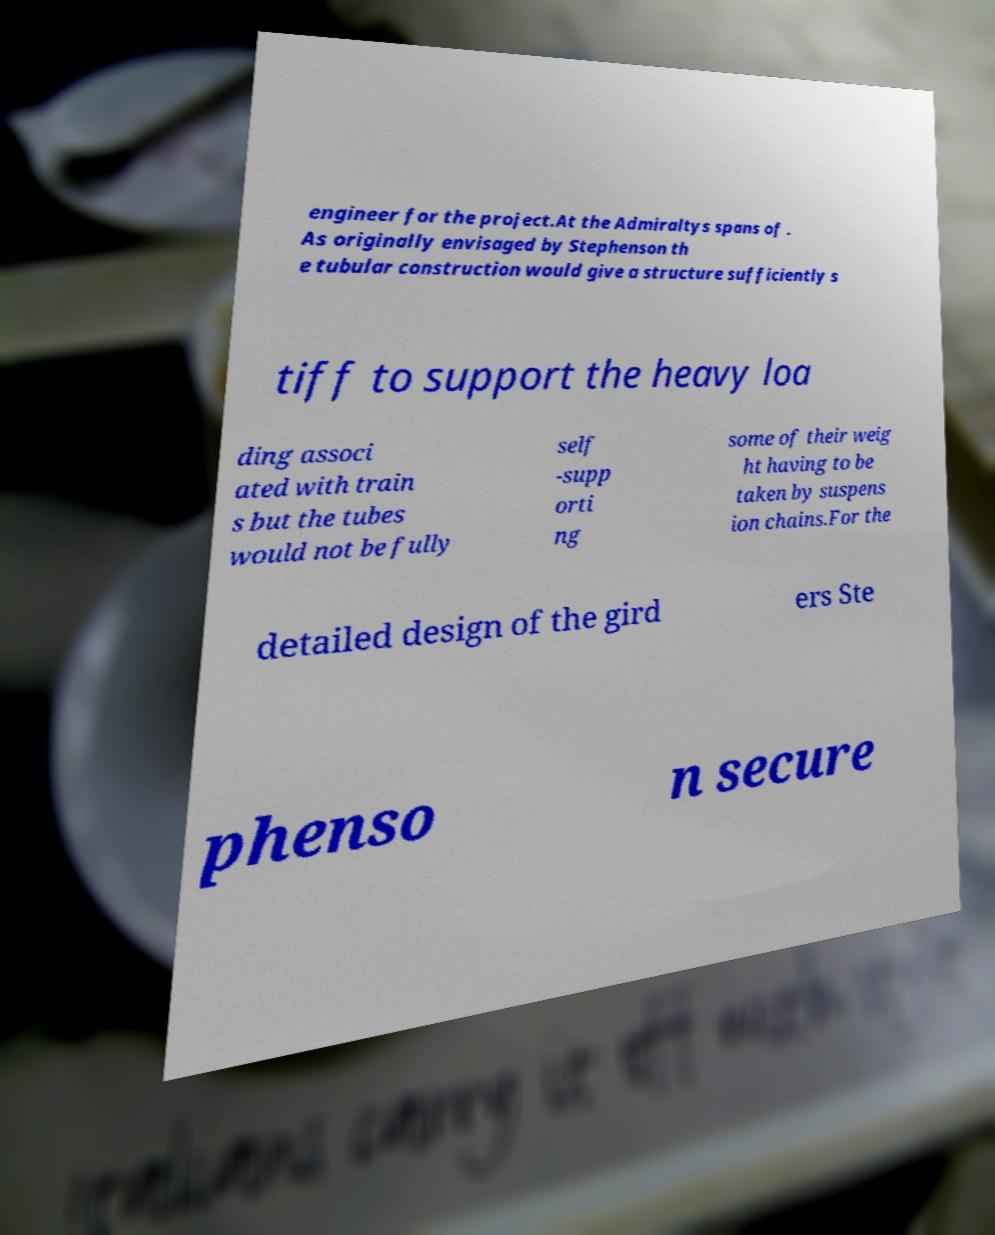There's text embedded in this image that I need extracted. Can you transcribe it verbatim? engineer for the project.At the Admiraltys spans of . As originally envisaged by Stephenson th e tubular construction would give a structure sufficiently s tiff to support the heavy loa ding associ ated with train s but the tubes would not be fully self -supp orti ng some of their weig ht having to be taken by suspens ion chains.For the detailed design of the gird ers Ste phenso n secure 